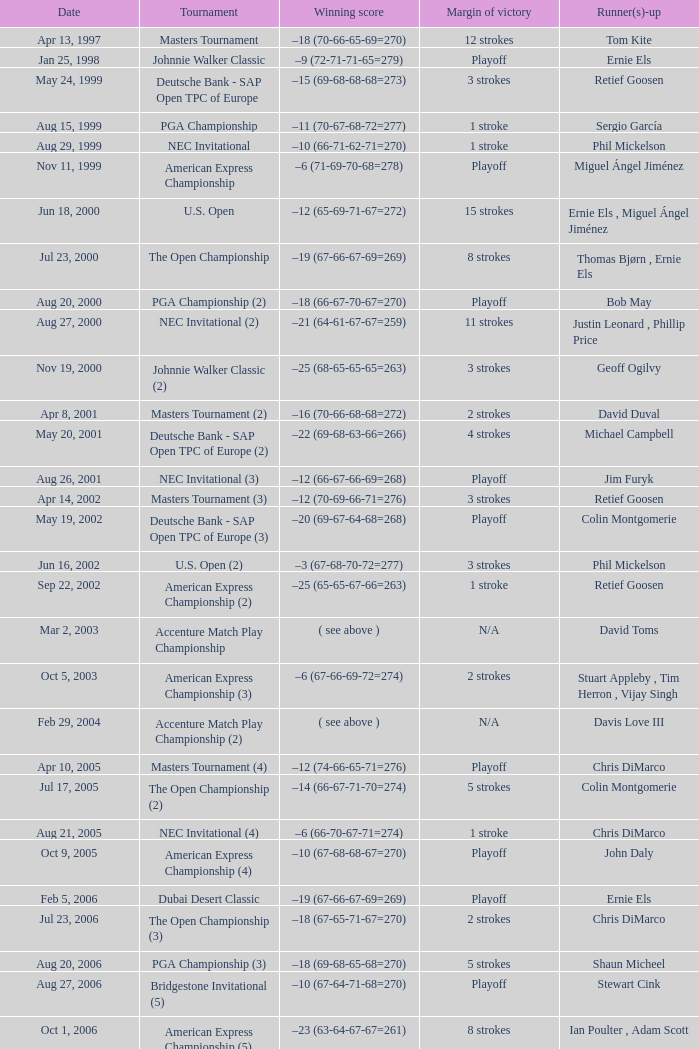Who possesses the victorious score of -10 (66-71-62-71=270)? Phil Mickelson. 